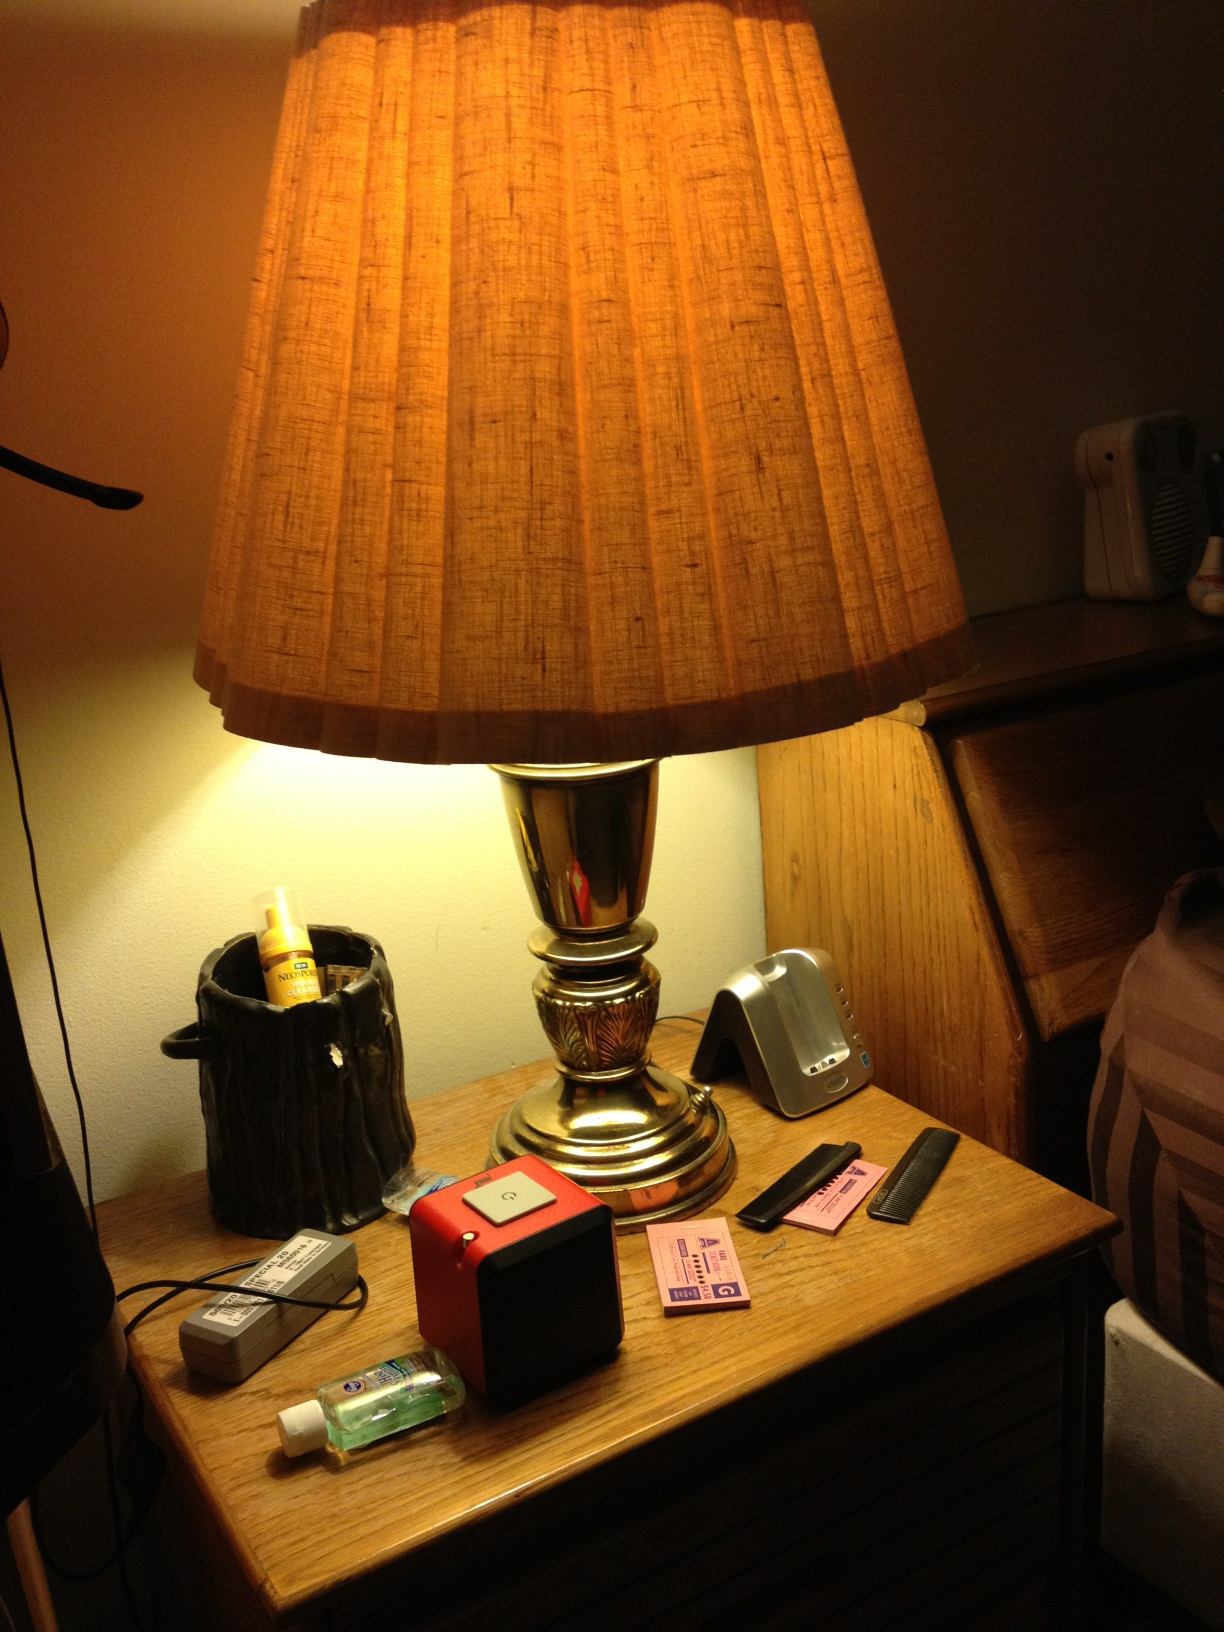Describe a realistic night-time scenario taking place in this room with the light on. It's late in the evening, and the room is bathed in the warm, comforting glow of the lamp. Someone is sitting in a comfy chair beside the table, reading a captivating novel, the soft light perfect for nighttime reading. The gentle atmosphere is complemented by a slight hum from a nearby fan, providing the perfect ambiance for relaxation after a long day. The items on the table, such as the hand sanitizer and speaker, suggest readiness for a calming night's routine, perhaps with some soothing music playing softly from the speaker.  What's the mood this lighting creates in the room? The warm, amber light from the lamp creates a cozy and intimate atmosphere in the room. It evokes a sense of calm and comfort, making it an ideal setting for unwinding and relaxing. The gentle light is perfect for creating a peaceful environment to read, meditate, or simply enjoy a quiet moment.  What if this lamp light could project memories? Describe a scenario where this happens. Imagine that upon switching on the lamp, it not only lights up the room but also begins to project vivid, holographic memories into the air around it. The room is suddenly filled with moving images - cherished family moments, birthday celebrations, holiday gatherings, and quiet, intimate conversations. One person sits in awe on the edge of their bed, watching as the scenes of their life play out before them, enveloped in a flood of nostalgia and emotions. The lamp becomes a window into the past, allowing them to relive fond memories and share stories with loved ones, making the room a magical place of connection and reminiscing. 